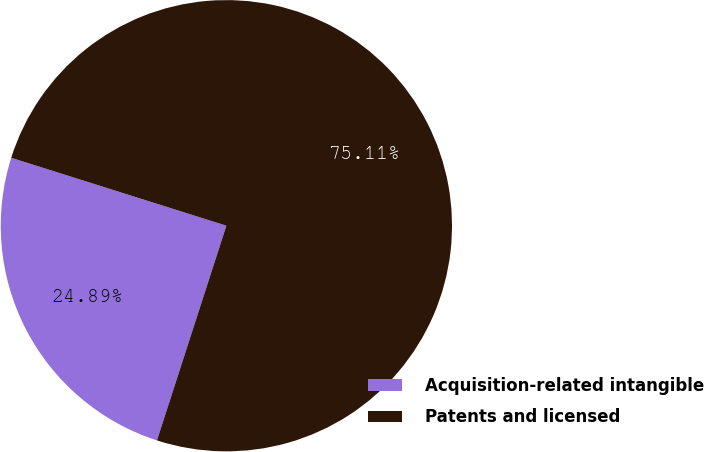Convert chart to OTSL. <chart><loc_0><loc_0><loc_500><loc_500><pie_chart><fcel>Acquisition-related intangible<fcel>Patents and licensed<nl><fcel>24.89%<fcel>75.11%<nl></chart> 